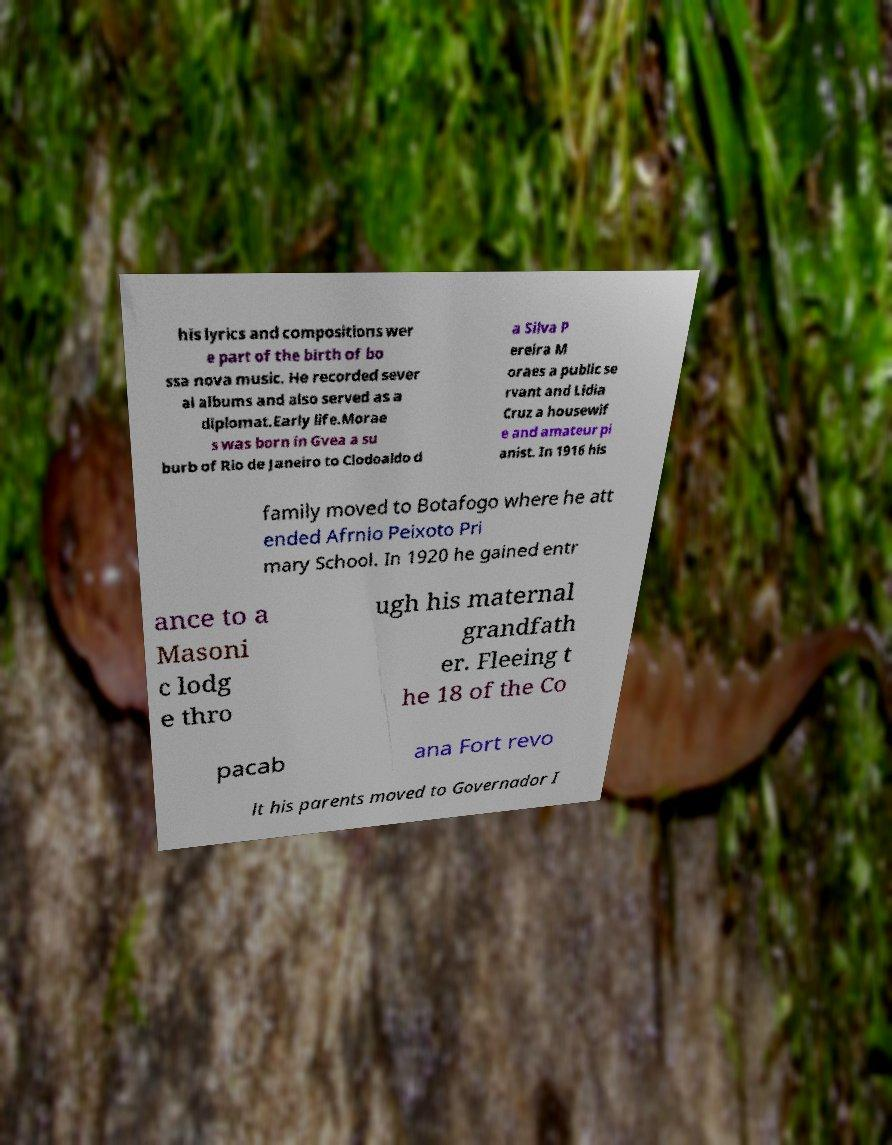Could you assist in decoding the text presented in this image and type it out clearly? his lyrics and compositions wer e part of the birth of bo ssa nova music. He recorded sever al albums and also served as a diplomat.Early life.Morae s was born in Gvea a su burb of Rio de Janeiro to Clodoaldo d a Silva P ereira M oraes a public se rvant and Lidia Cruz a housewif e and amateur pi anist. In 1916 his family moved to Botafogo where he att ended Afrnio Peixoto Pri mary School. In 1920 he gained entr ance to a Masoni c lodg e thro ugh his maternal grandfath er. Fleeing t he 18 of the Co pacab ana Fort revo lt his parents moved to Governador I 